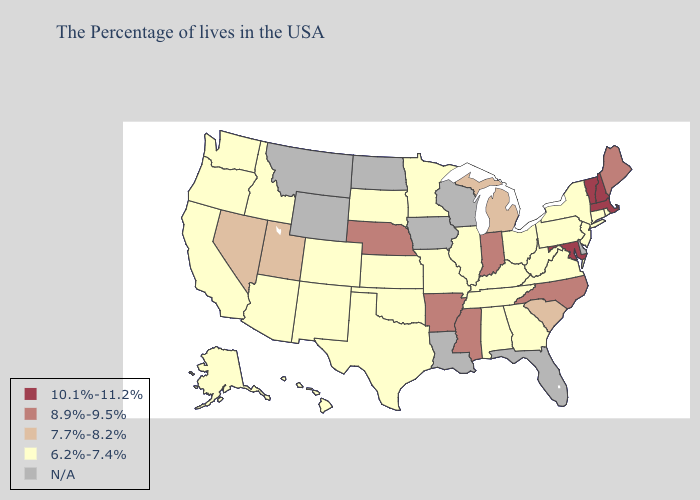Name the states that have a value in the range 8.9%-9.5%?
Be succinct. Maine, North Carolina, Indiana, Mississippi, Arkansas, Nebraska. Among the states that border Tennessee , does Kentucky have the highest value?
Answer briefly. No. What is the highest value in the West ?
Write a very short answer. 7.7%-8.2%. Name the states that have a value in the range 7.7%-8.2%?
Concise answer only. South Carolina, Michigan, Utah, Nevada. Does the map have missing data?
Keep it brief. Yes. What is the value of North Dakota?
Quick response, please. N/A. Does the first symbol in the legend represent the smallest category?
Write a very short answer. No. What is the value of New Mexico?
Give a very brief answer. 6.2%-7.4%. What is the value of Illinois?
Write a very short answer. 6.2%-7.4%. Does the first symbol in the legend represent the smallest category?
Be succinct. No. Name the states that have a value in the range N/A?
Give a very brief answer. Delaware, Florida, Wisconsin, Louisiana, Iowa, North Dakota, Wyoming, Montana. What is the lowest value in states that border Kansas?
Write a very short answer. 6.2%-7.4%. What is the value of Florida?
Write a very short answer. N/A. 